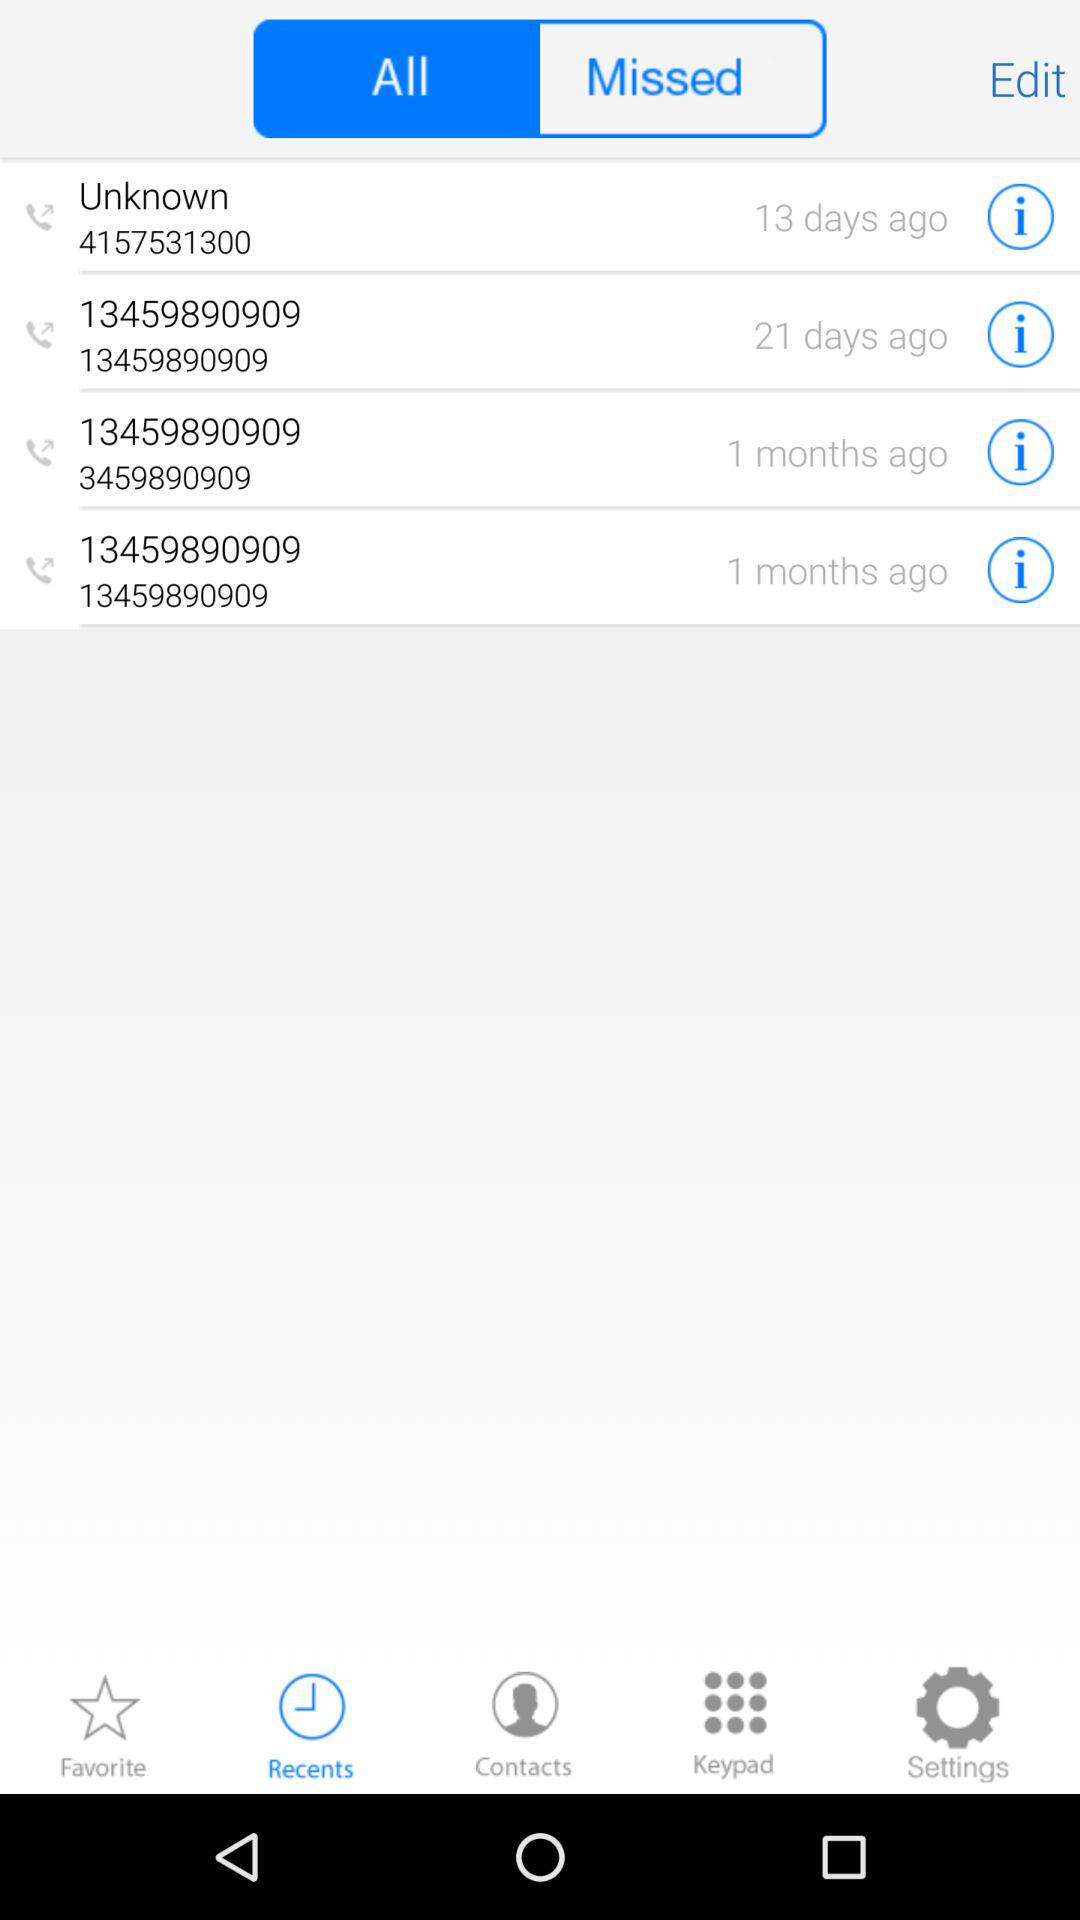How many days ago was the call made to the unknown number? The call was made 13 days ago. 